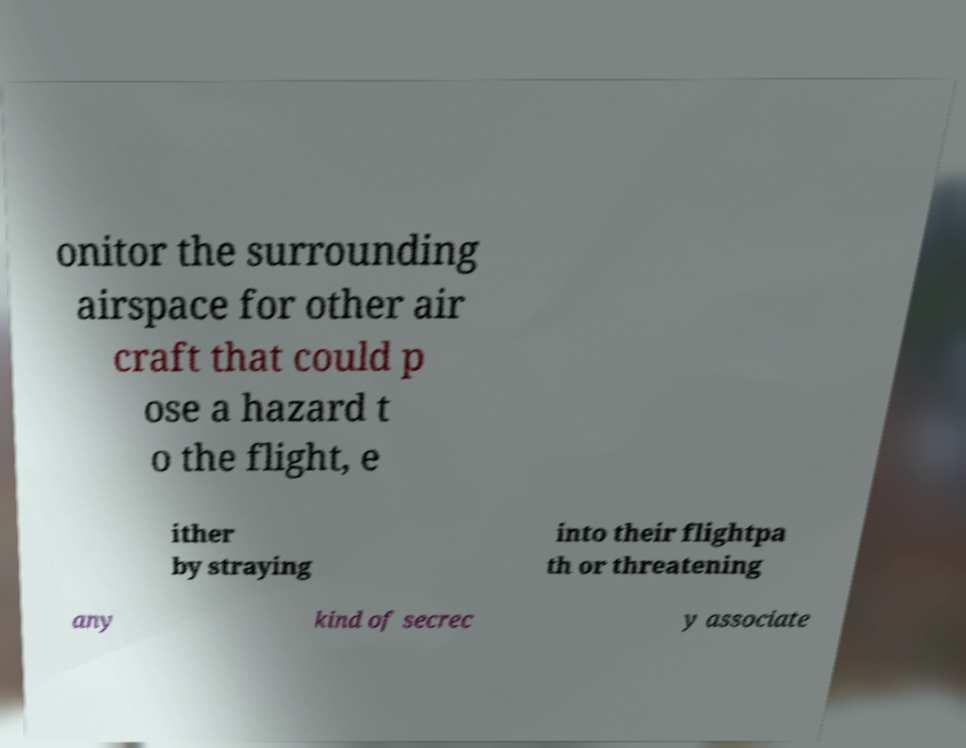Can you read and provide the text displayed in the image?This photo seems to have some interesting text. Can you extract and type it out for me? onitor the surrounding airspace for other air craft that could p ose a hazard t o the flight, e ither by straying into their flightpa th or threatening any kind of secrec y associate 